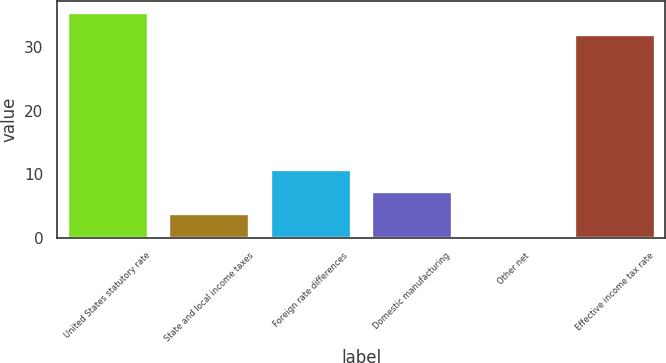Convert chart to OTSL. <chart><loc_0><loc_0><loc_500><loc_500><bar_chart><fcel>United States statutory rate<fcel>State and local income taxes<fcel>Foreign rate differences<fcel>Domestic manufacturing<fcel>Other net<fcel>Effective income tax rate<nl><fcel>35.55<fcel>3.95<fcel>10.85<fcel>7.4<fcel>0.5<fcel>32.1<nl></chart> 